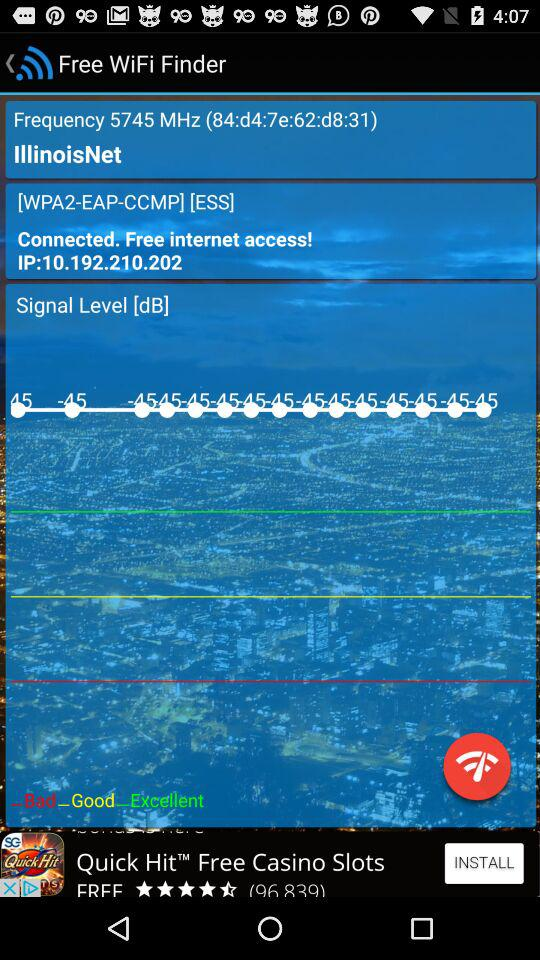How many dB is the signal strength of the network?
Answer the question using a single word or phrase. -45 